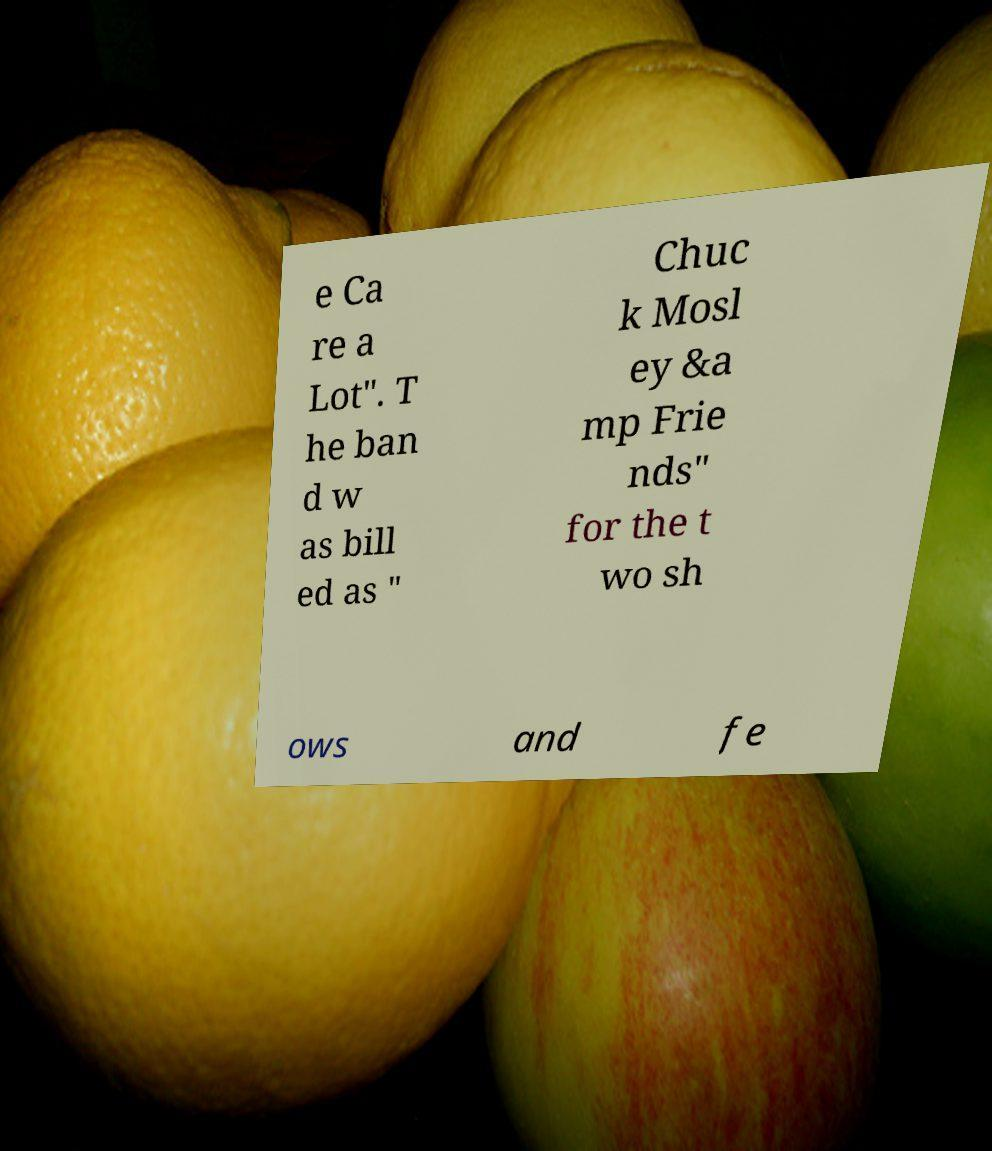Could you extract and type out the text from this image? e Ca re a Lot". T he ban d w as bill ed as " Chuc k Mosl ey &a mp Frie nds" for the t wo sh ows and fe 